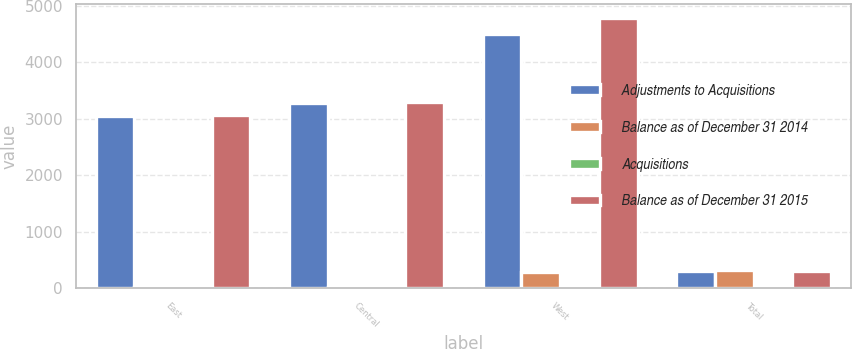<chart> <loc_0><loc_0><loc_500><loc_500><stacked_bar_chart><ecel><fcel>East<fcel>Central<fcel>West<fcel>Total<nl><fcel>Adjustments to Acquisitions<fcel>3046<fcel>3279<fcel>4505.9<fcel>295.85<nl><fcel>Balance as of December 31 2014<fcel>16.7<fcel>16.2<fcel>279.4<fcel>312.3<nl><fcel>Acquisitions<fcel>0.4<fcel>0.5<fcel>3.2<fcel>2.3<nl><fcel>Balance as of December 31 2015<fcel>3062.3<fcel>3294.7<fcel>4788.5<fcel>295.85<nl></chart> 